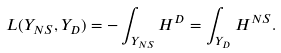Convert formula to latex. <formula><loc_0><loc_0><loc_500><loc_500>L ( Y _ { N S } , Y _ { D } ) = - \int _ { Y _ { N S } } H ^ { D } = \int _ { Y _ { D } } H ^ { N S } .</formula> 